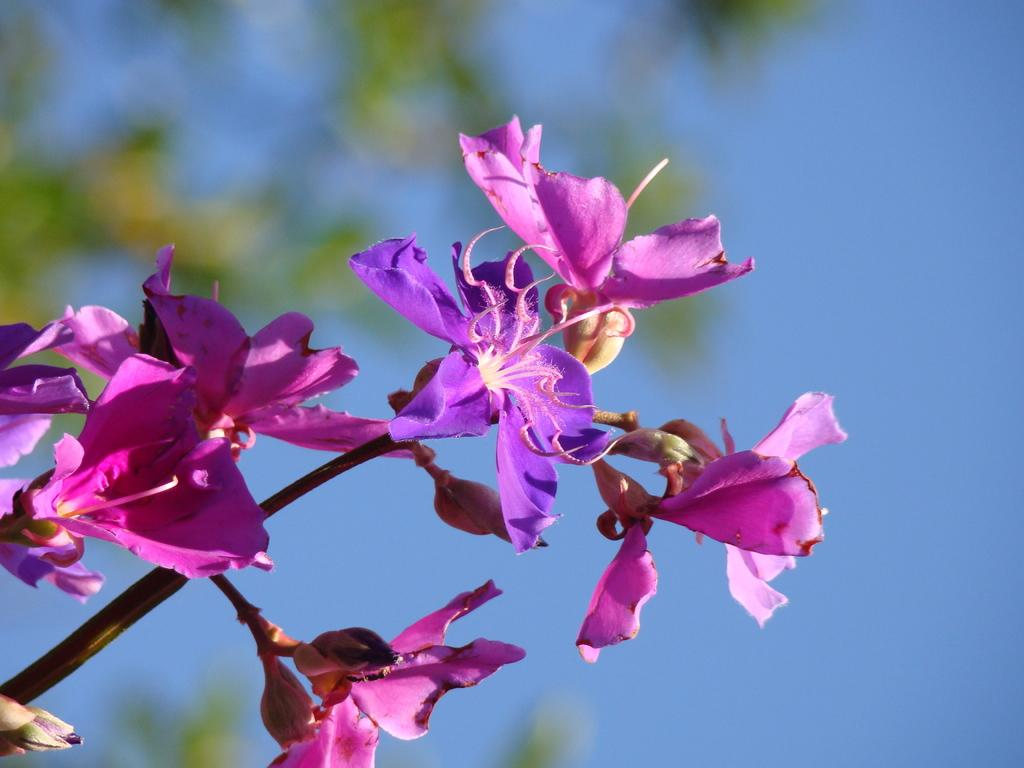What is present on the branch in the image? There are flowers on a branch in the image. Can you describe the branch's possible origin? The branch might be part of a tree. What can be seen in the top right corner of the image? The sky is visible at the top right of the image. What type of glove is being used to fulfill the character's desire in the image? There is no glove or character present in the image, and therefore no such activity can be observed. 